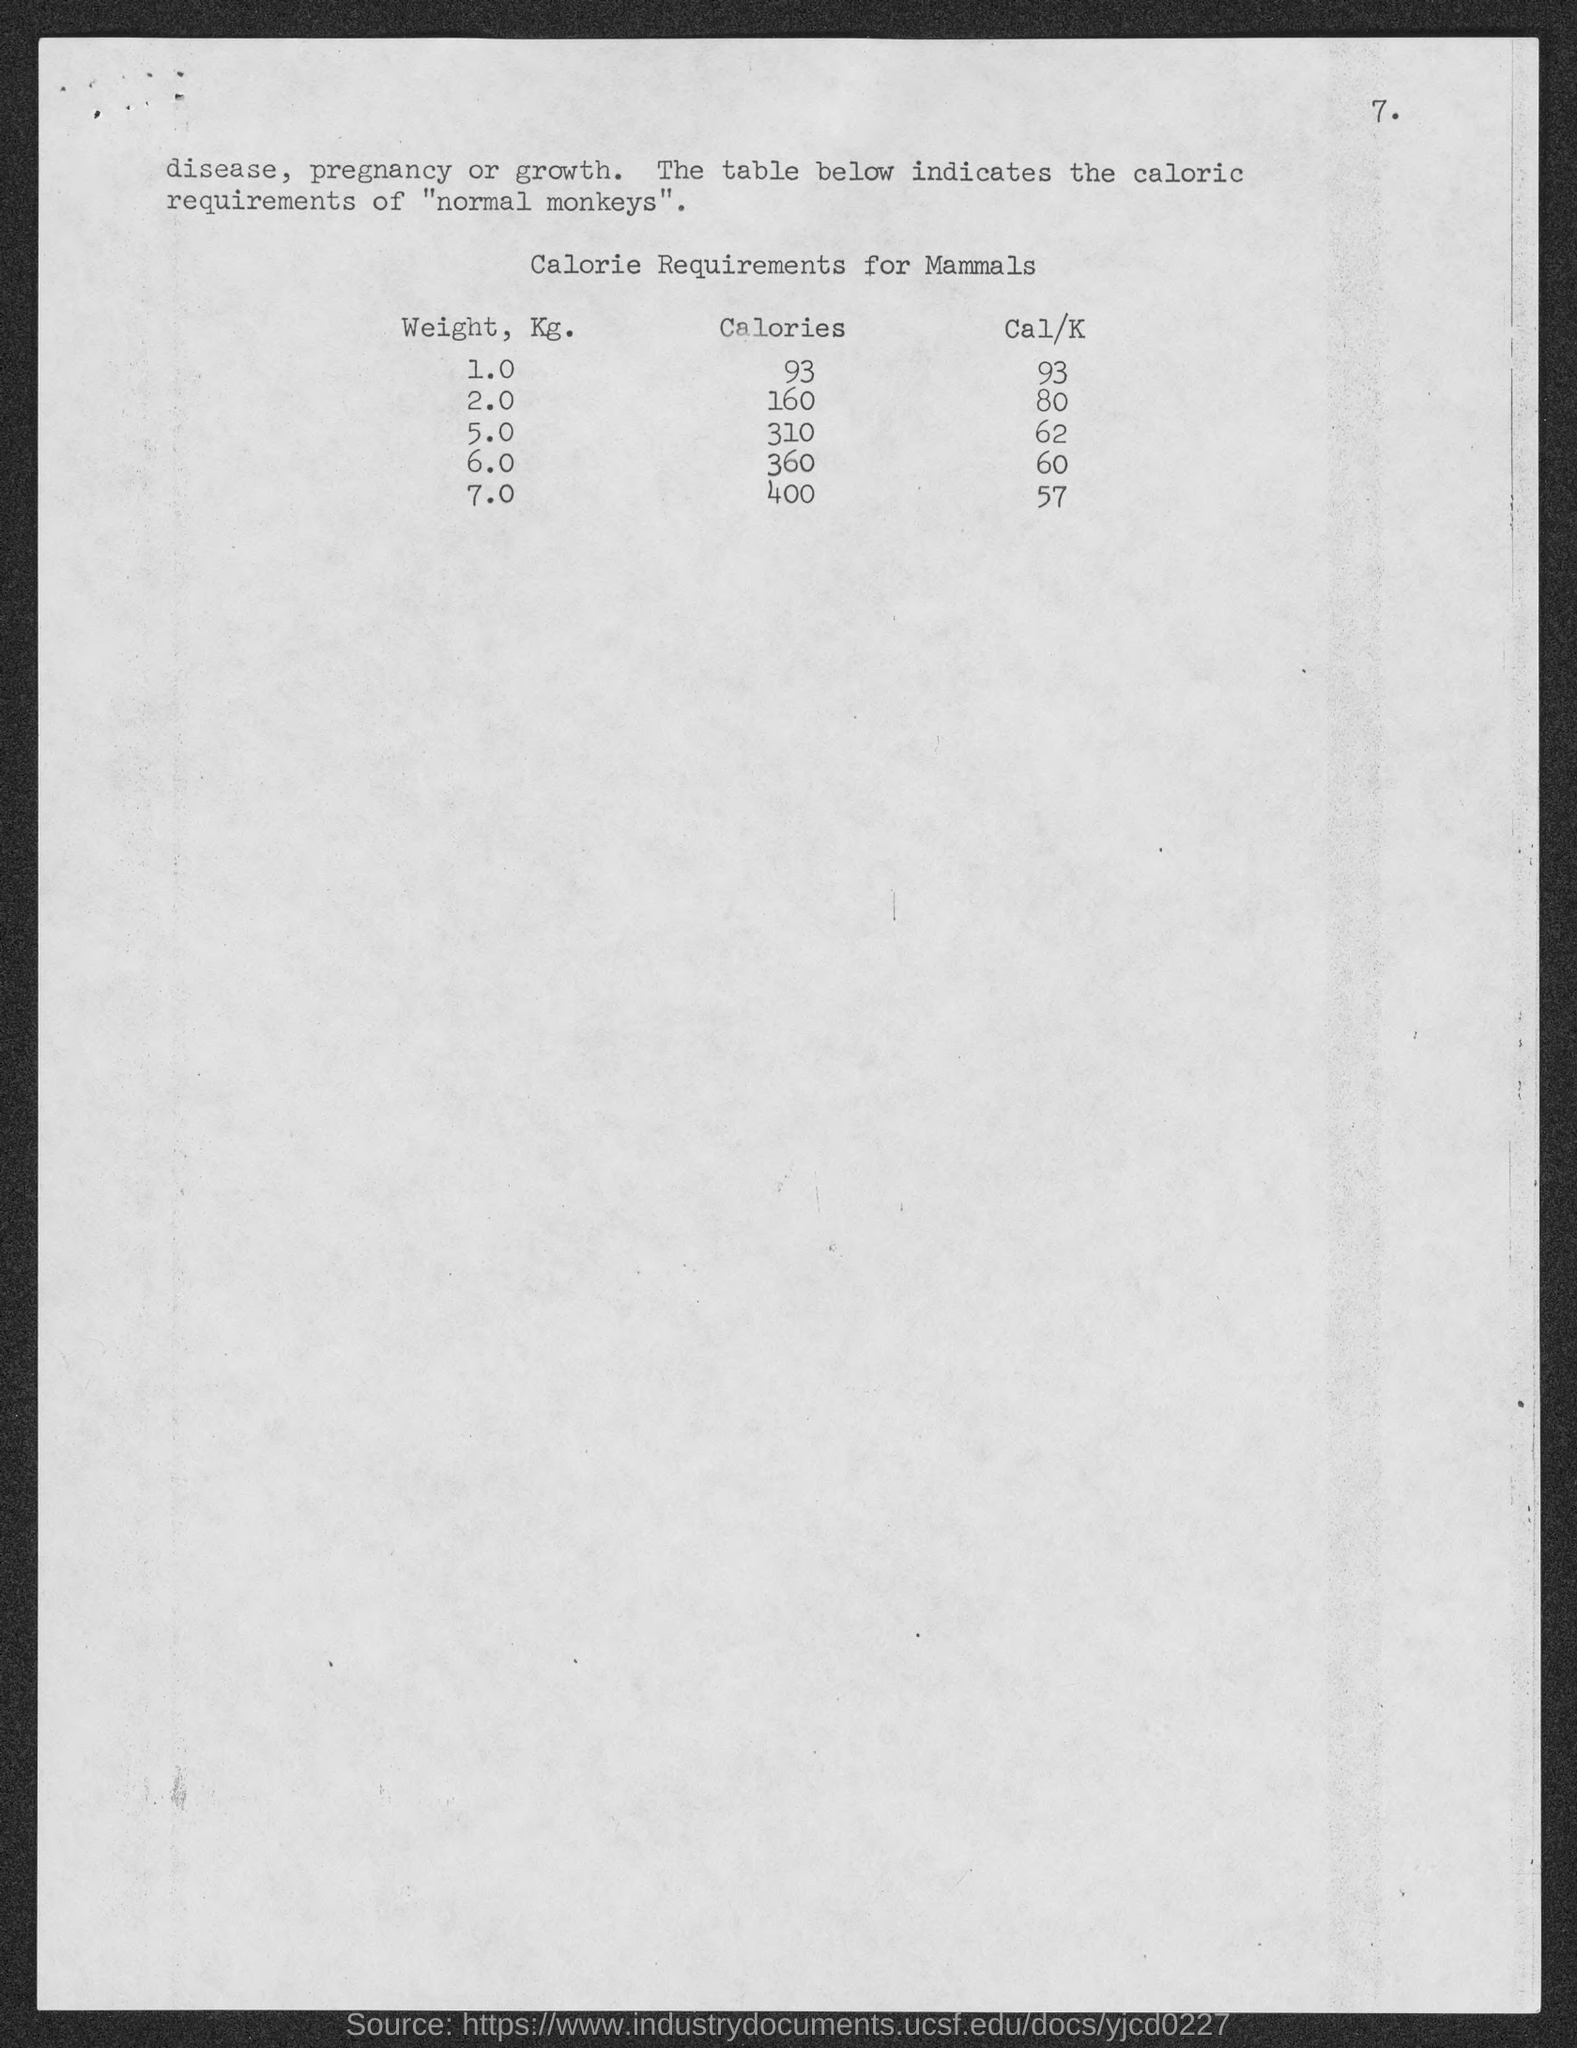List a handful of essential elements in this visual. The table heading is "Calorie Requirements for Mammals. A 2-kilogram mammal requires a specific number of calories for proper nutrition and energy intake. The amount of calories required for 1 kg of mammals is 93. The highest weight of mammals shown in the table is 7.0 kilograms. The amount of energy required for a 2-kilogram mammal is approximately 80 Cal/K. 